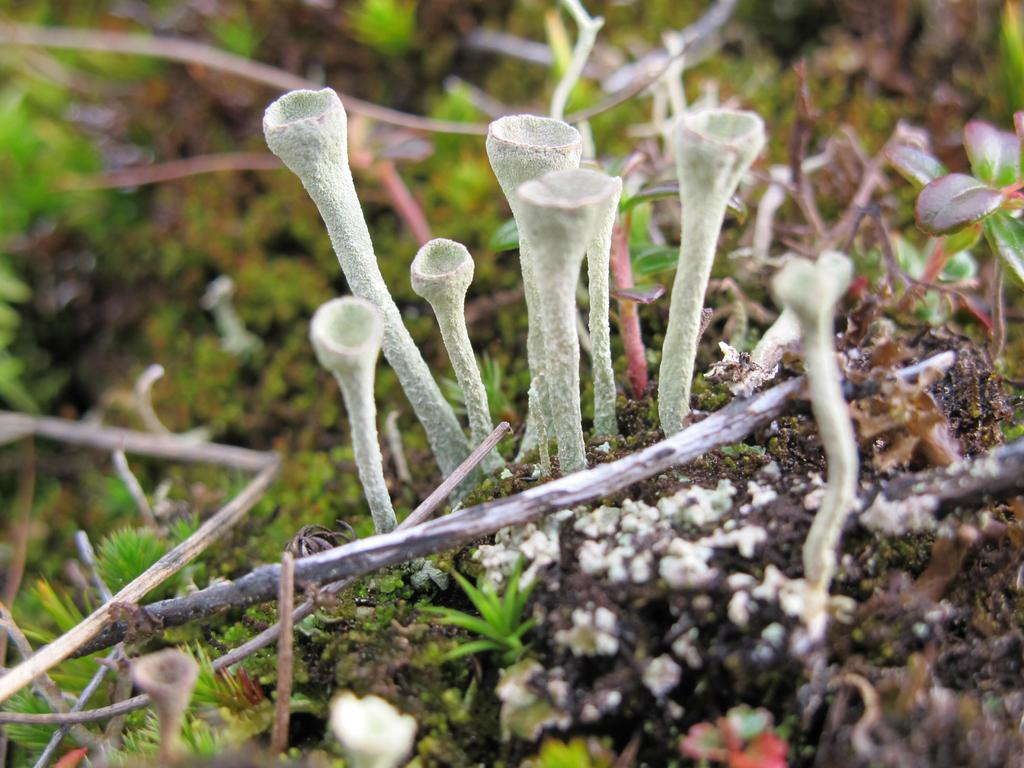What type of fungi can be seen in the image? There are mushrooms in the image. What other types of vegetation are present in the image? There are plants and grass in the image. What is the ground made of in the image? There is mud in the image. How many beggars can be seen in the image? There are no beggars present in the image. What type of amphibians can be seen hopping around in the image? There are no frogs present in the image. 